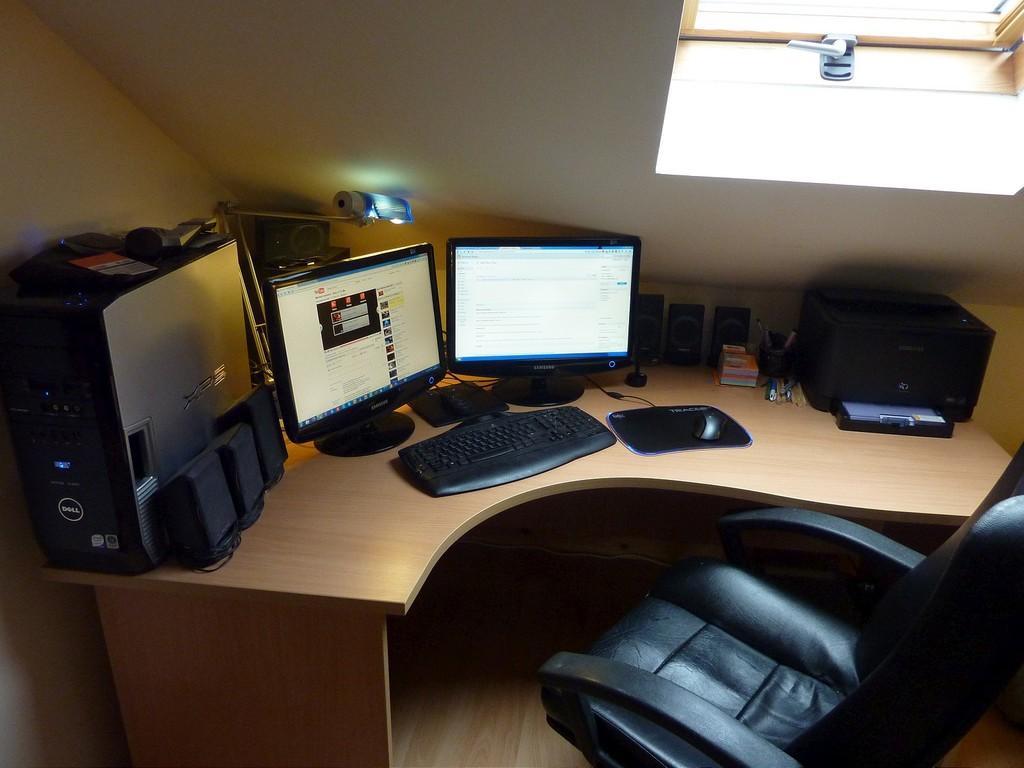How would you summarize this image in a sentence or two? In this image inside view of room. And there is table visible,on the table there are the systems and there is a monitor and there is a keypad and there is a cpu kept on the left side and there is a camera visible and there is a light visible and there is a chair on the ground visible. 